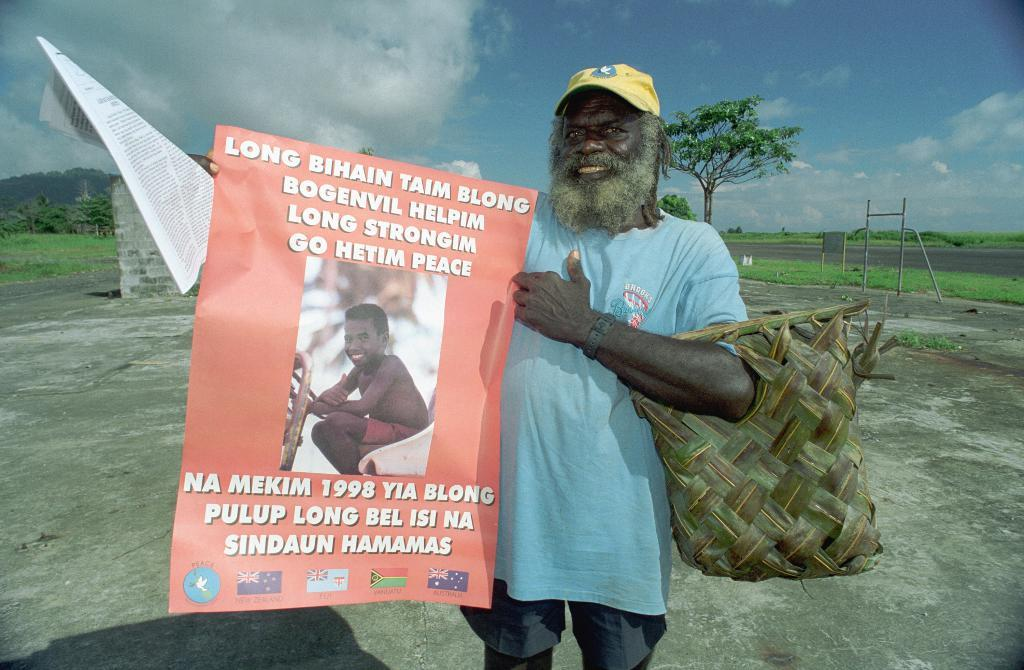Who is present in the image? There is a person in the image. What is the person doing in the image? The person is smiling and holding a banner. What is the natural environment like in the image? There is green grass and trees in the image. What can be seen in the sky in the image? There are clouds in the sky. What type of sticks are used to paint the person's face in the image? There are no sticks or paint present in the image, and therefore no such activity can be observed. How many screws are visible on the person's clothing in the image? There are no screws visible on the person's clothing in the image. 